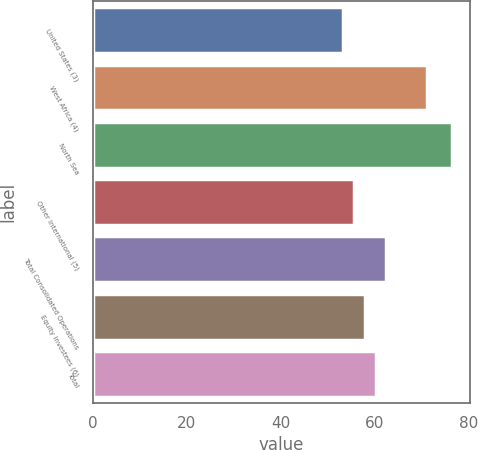<chart> <loc_0><loc_0><loc_500><loc_500><bar_chart><fcel>United States (3)<fcel>West Africa (4)<fcel>North Sea<fcel>Other International (5)<fcel>Total Consolidated Operations<fcel>Equity Investees (6)<fcel>Total<nl><fcel>53.22<fcel>71.27<fcel>76.47<fcel>55.55<fcel>62.54<fcel>57.88<fcel>60.21<nl></chart> 